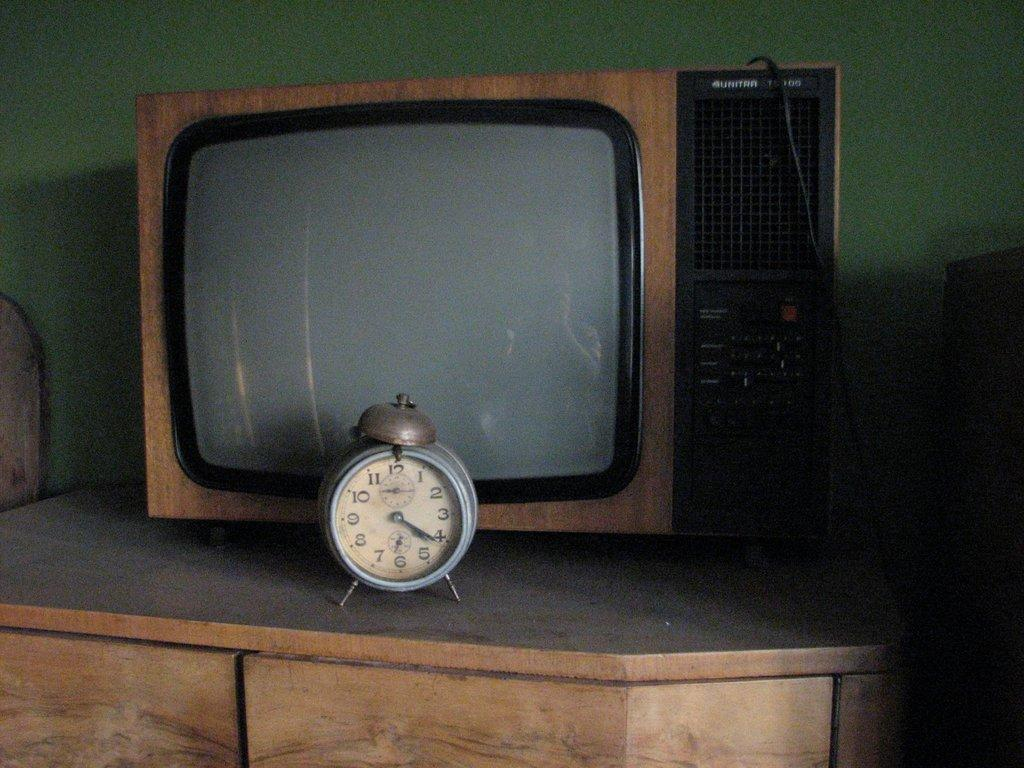<image>
Offer a succinct explanation of the picture presented. A clock showing the time to be a little after 4:20 sits on a stand in front of a Unitra brand TV. 